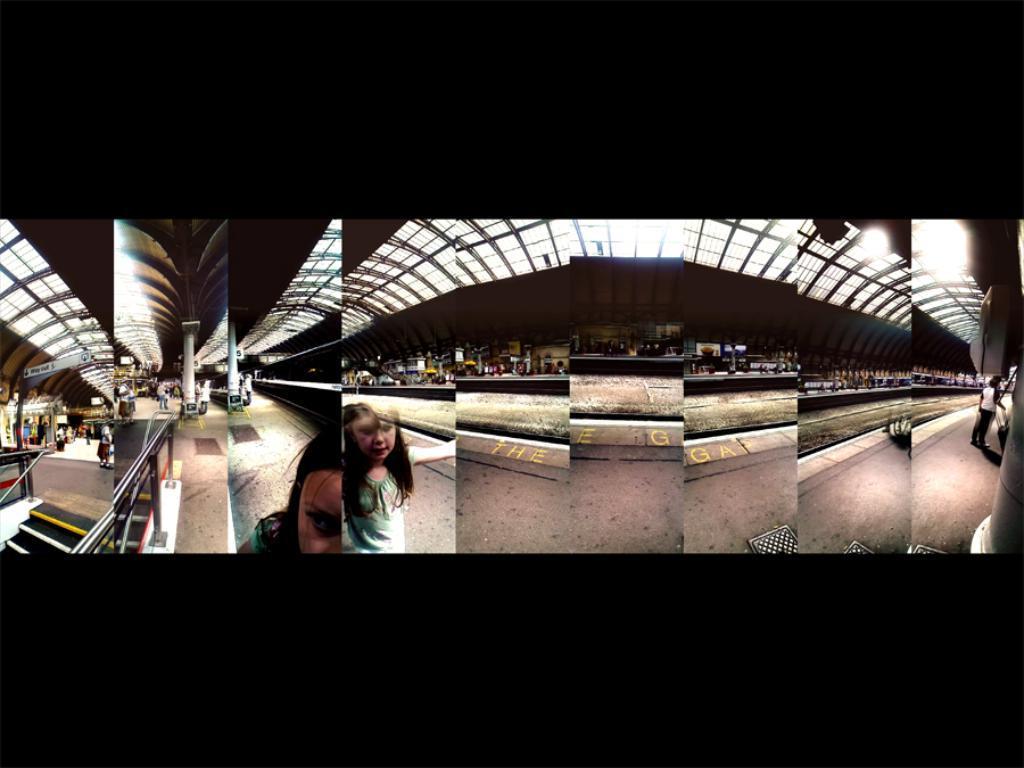Please provide a concise description of this image. It is a collage picture. In the image we can see a platform, on the platform few people are walking. Bottom left side of the image there are some steps. 